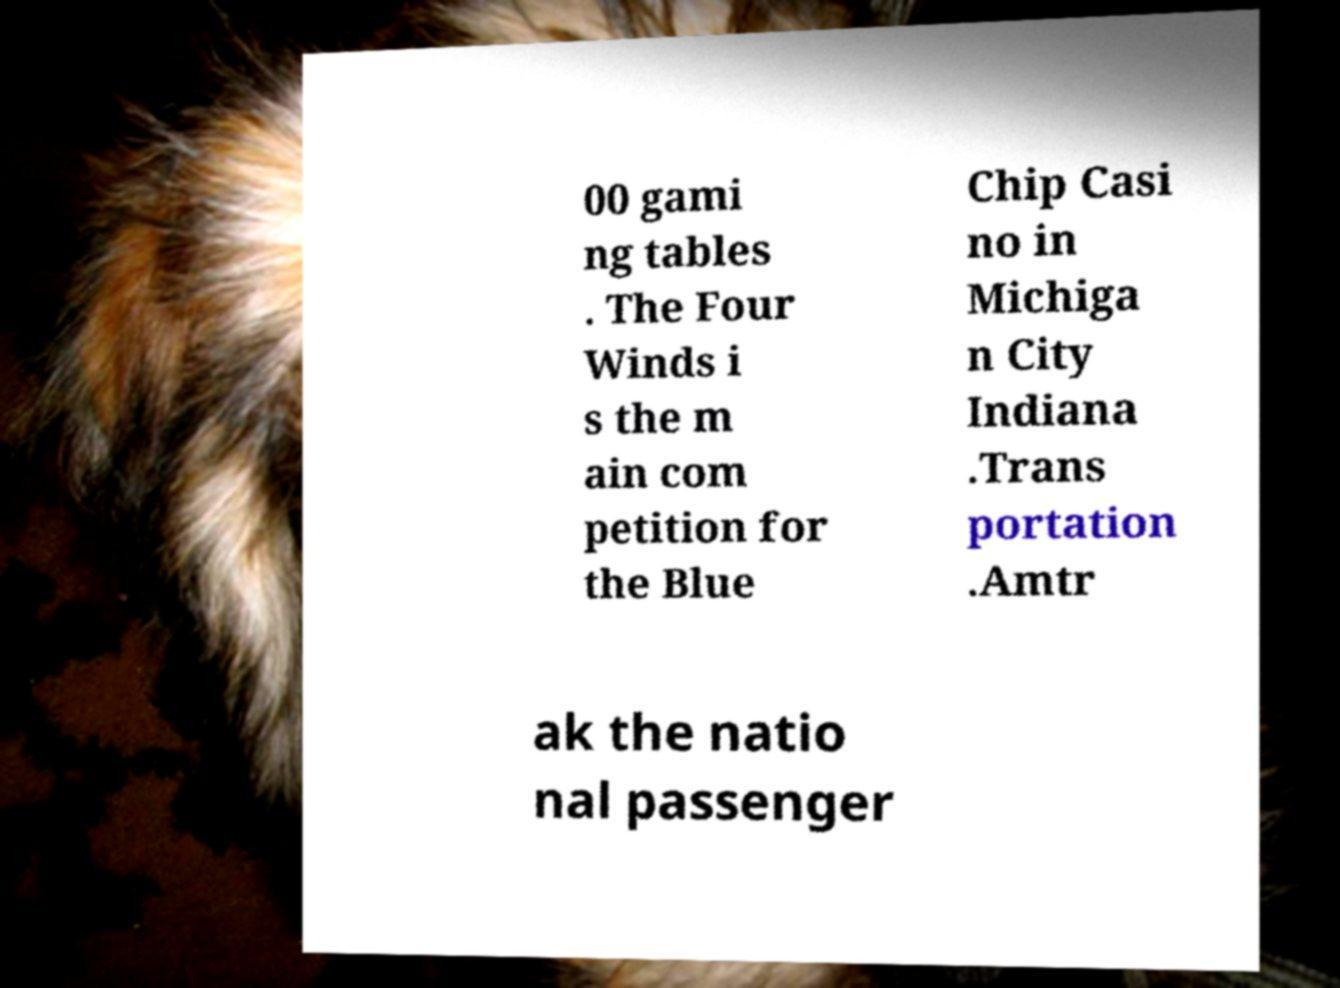Please identify and transcribe the text found in this image. 00 gami ng tables . The Four Winds i s the m ain com petition for the Blue Chip Casi no in Michiga n City Indiana .Trans portation .Amtr ak the natio nal passenger 